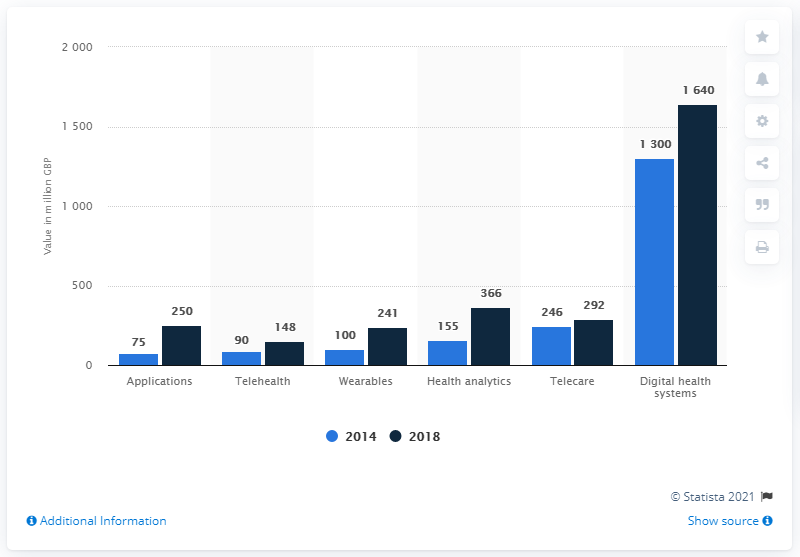Point out several critical features in this image. The estimated value of the health analytics market in the UK in 2018 was 366 million. 